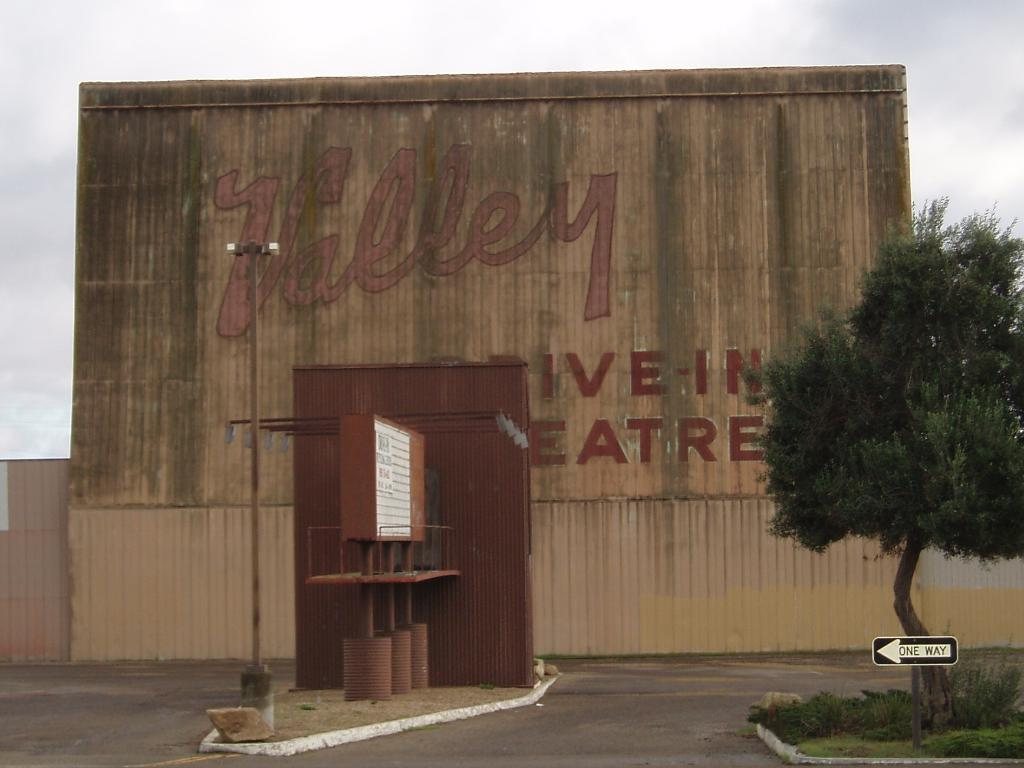What type of vegetation can be seen in the image? There is a tree and plants in the image. What structure is attached to a pole in the image? There is a board attached to a pole in the image. What type of background is visible in the image? It appears to be a wall in the image, and the sky is visible in the background. Can you see a ring being worn by the tree in the image? There is no ring visible on the tree in the image. Are there any horses present in the image? There are no horses present in the image. 